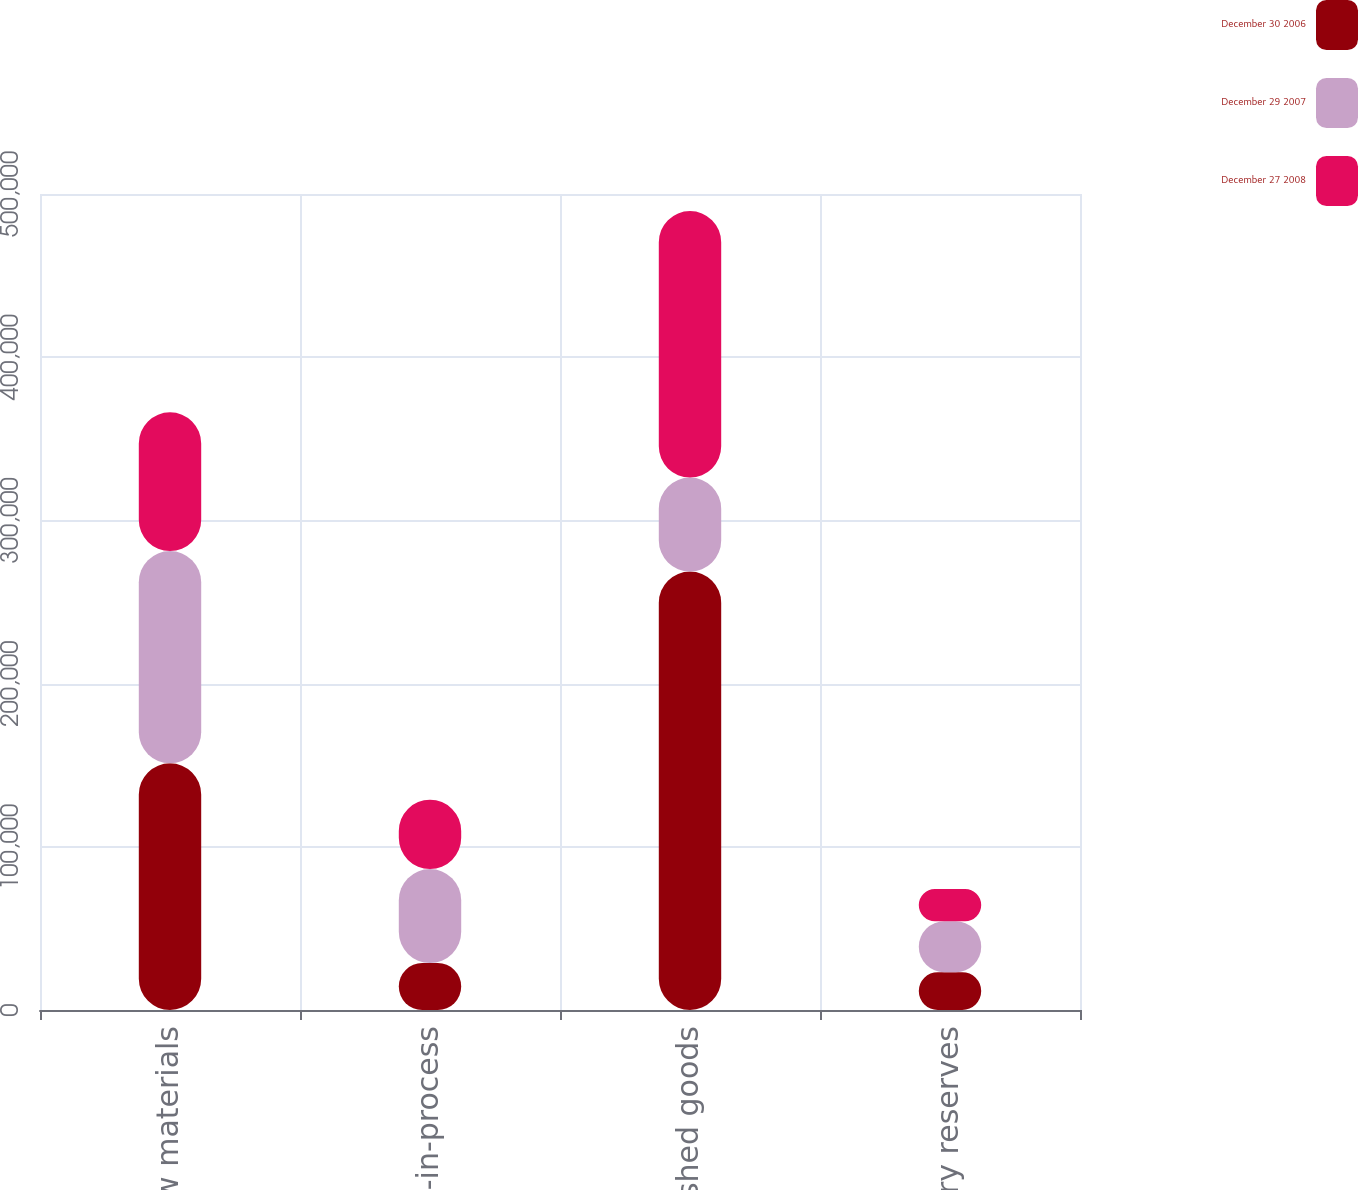Convert chart to OTSL. <chart><loc_0><loc_0><loc_500><loc_500><stacked_bar_chart><ecel><fcel>Raw materials<fcel>Work-in-process<fcel>Finished goods<fcel>Inventory reserves<nl><fcel>December 30 2006<fcel>151132<fcel>28759<fcel>268625<fcel>23204<nl><fcel>December 29 2007<fcel>130056<fcel>57622<fcel>57622<fcel>31186<nl><fcel>December 27 2008<fcel>85040<fcel>42450<fcel>163286<fcel>19768<nl></chart> 